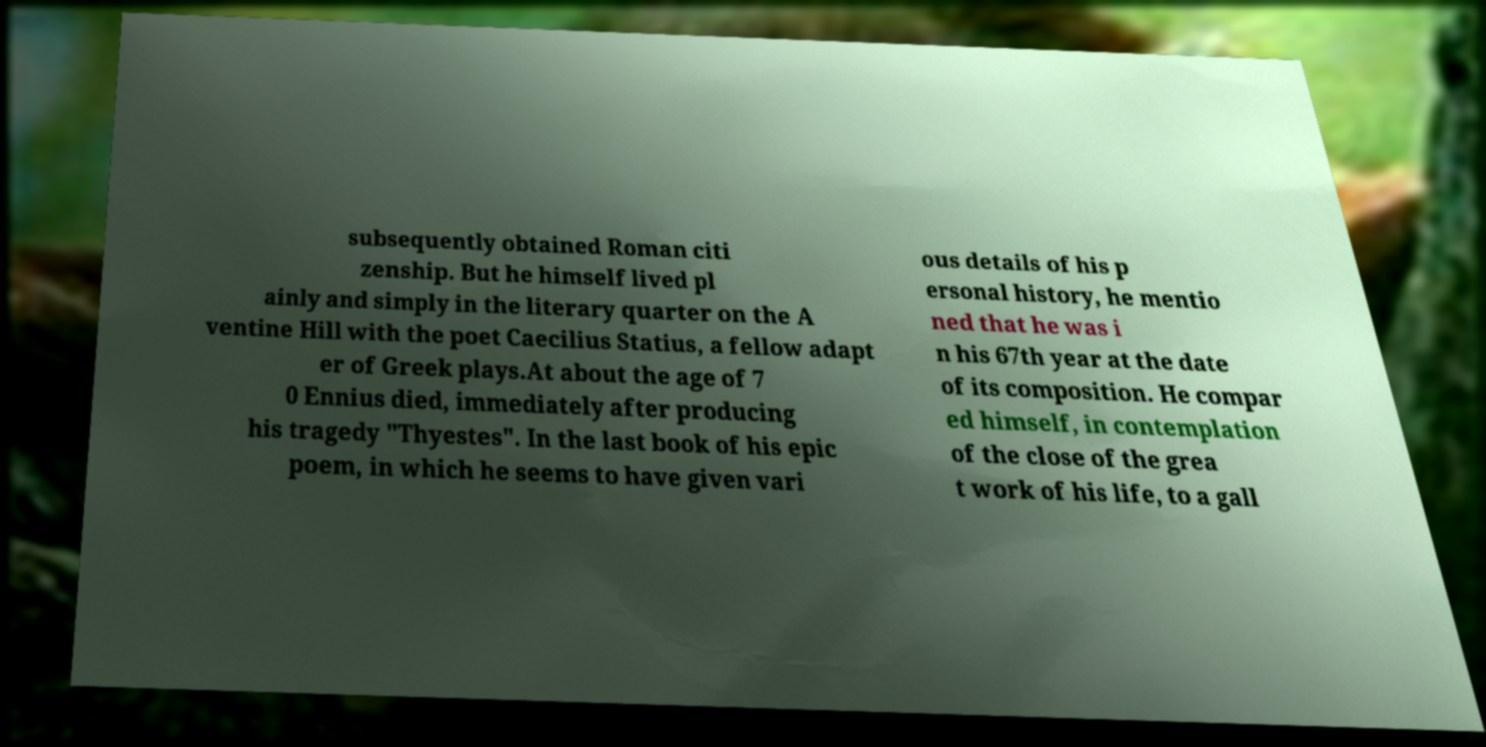For documentation purposes, I need the text within this image transcribed. Could you provide that? subsequently obtained Roman citi zenship. But he himself lived pl ainly and simply in the literary quarter on the A ventine Hill with the poet Caecilius Statius, a fellow adapt er of Greek plays.At about the age of 7 0 Ennius died, immediately after producing his tragedy "Thyestes". In the last book of his epic poem, in which he seems to have given vari ous details of his p ersonal history, he mentio ned that he was i n his 67th year at the date of its composition. He compar ed himself, in contemplation of the close of the grea t work of his life, to a gall 